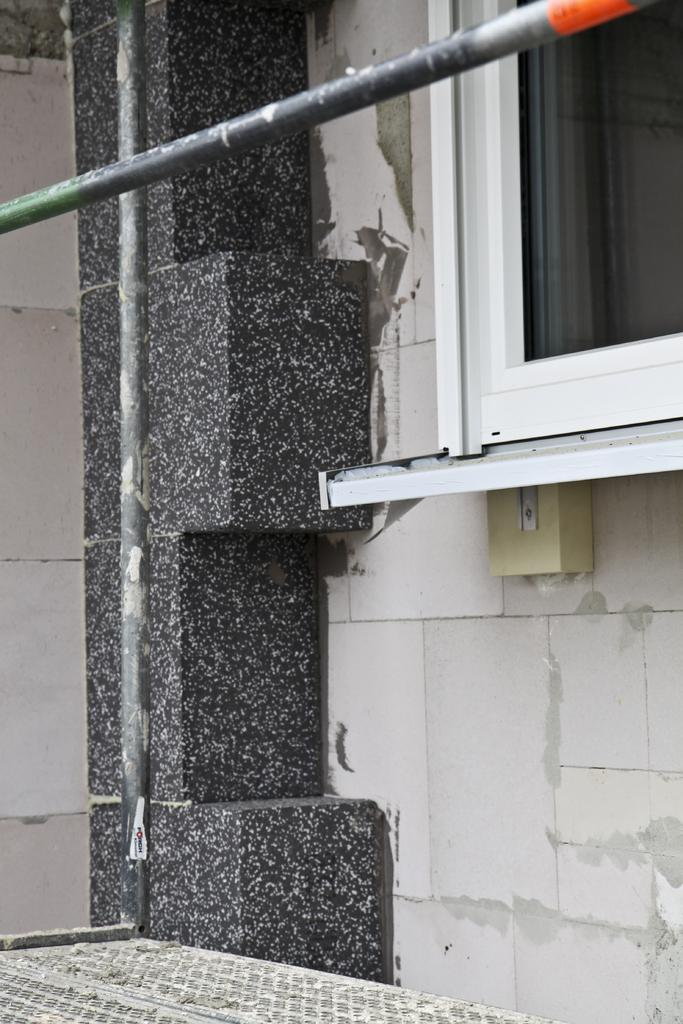What is the color of the wall in the image? The wall in the image is cream in color. What is the color pattern of the pillar in the image? The pillar in the image is white and black in color. What type of roofs can be seen in the image? Metal roofs are visible in the image. Is there any opening in the wall in the image? Yes, there is a window in the image. What object in the image shares the same color as the wall? There is an object in the image that is cream in color and attached to the wall. How far away is the card from the comfort zone in the image? There is no card or comfort zone present in the image. 